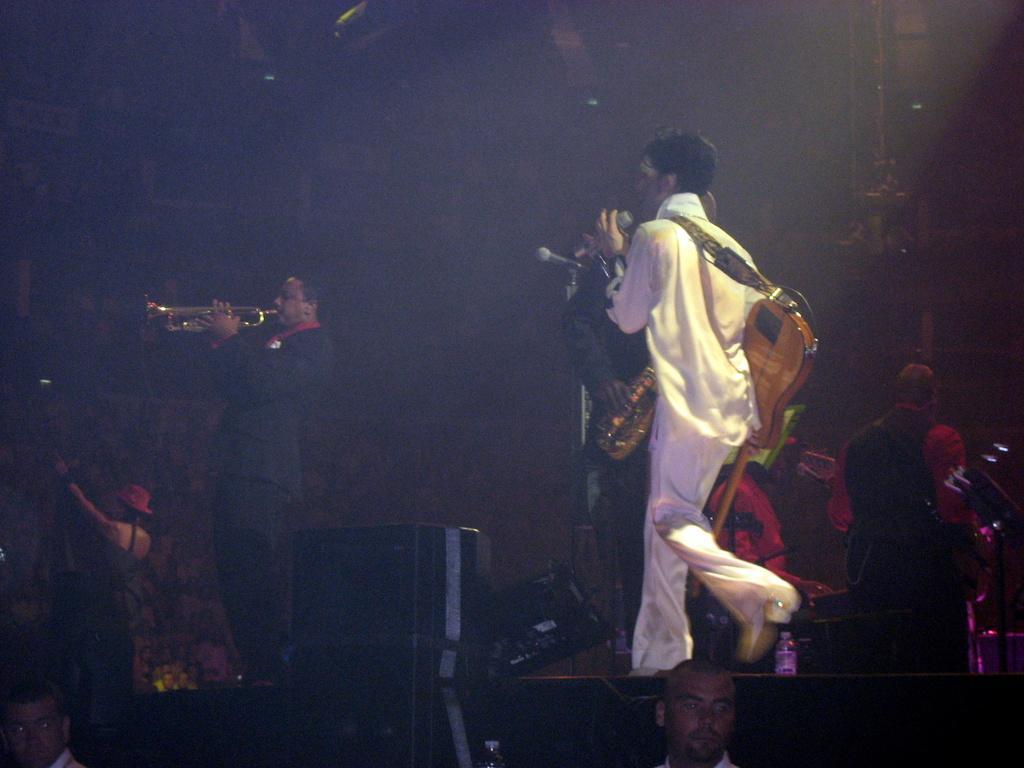Please provide a concise description of this image. This picture seems to be clicked inside. On the right there is a person wearing a guitar, holding a microphone and walking on the ground. On the left there is another person playing trumpet and standing on the ground. In the background we can see the group of people and some other objects. 